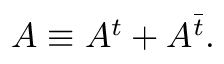<formula> <loc_0><loc_0><loc_500><loc_500>A \equiv A ^ { t } + A ^ { \bar { t } } .</formula> 